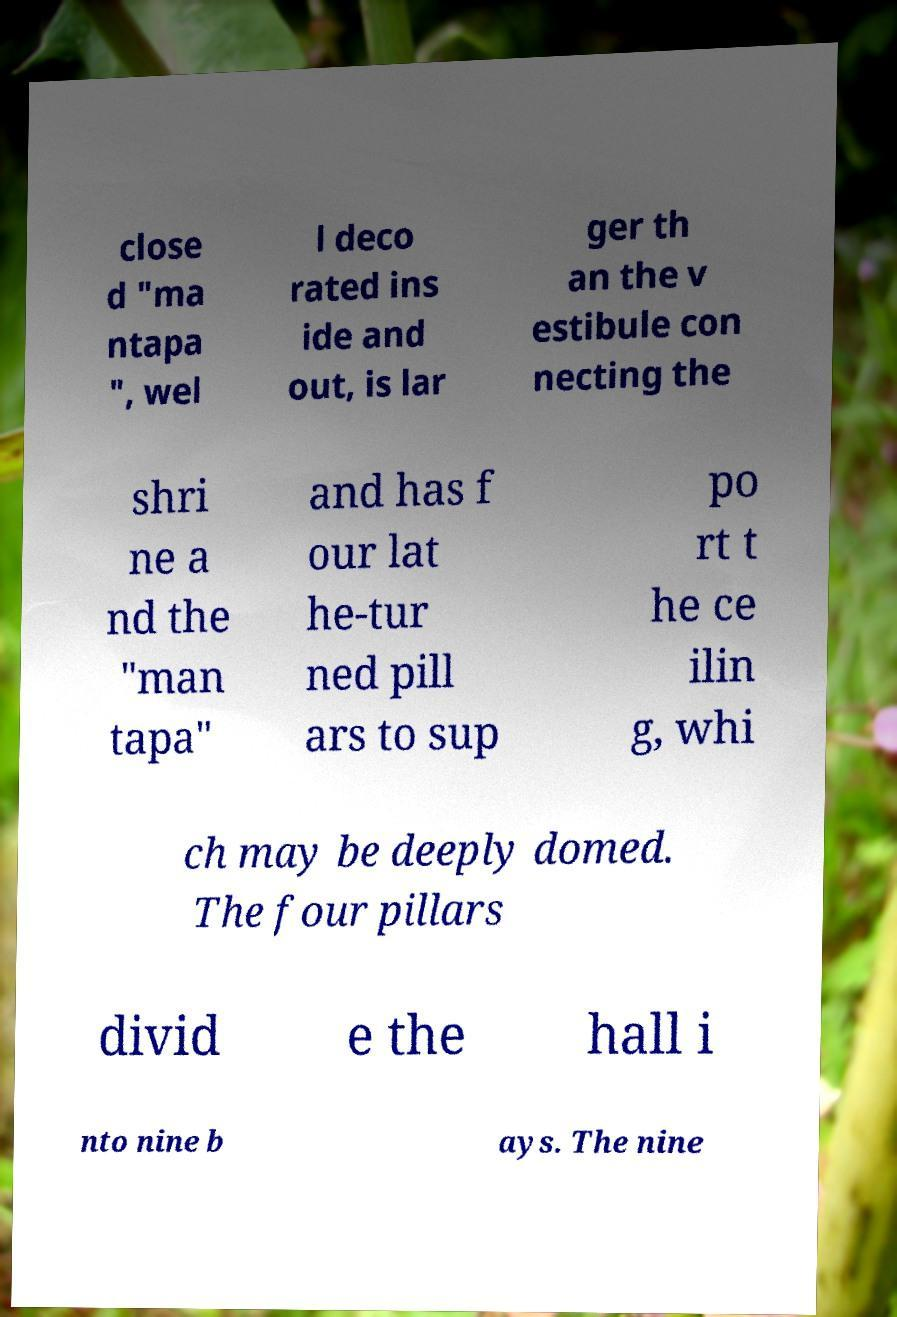Can you accurately transcribe the text from the provided image for me? close d "ma ntapa ", wel l deco rated ins ide and out, is lar ger th an the v estibule con necting the shri ne a nd the "man tapa" and has f our lat he-tur ned pill ars to sup po rt t he ce ilin g, whi ch may be deeply domed. The four pillars divid e the hall i nto nine b ays. The nine 